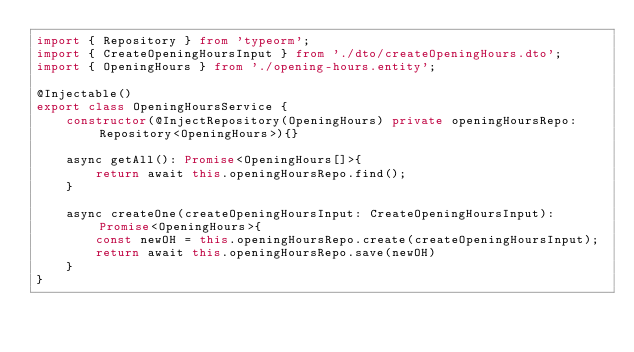Convert code to text. <code><loc_0><loc_0><loc_500><loc_500><_TypeScript_>import { Repository } from 'typeorm';
import { CreateOpeningHoursInput } from './dto/createOpeningHours.dto';
import { OpeningHours } from './opening-hours.entity';

@Injectable()
export class OpeningHoursService {
    constructor(@InjectRepository(OpeningHours) private openingHoursRepo: Repository<OpeningHours>){}

    async getAll(): Promise<OpeningHours[]>{
        return await this.openingHoursRepo.find();
    }

    async createOne(createOpeningHoursInput: CreateOpeningHoursInput): Promise<OpeningHours>{
        const newOH = this.openingHoursRepo.create(createOpeningHoursInput);
        return await this.openingHoursRepo.save(newOH)
    }
}
</code> 